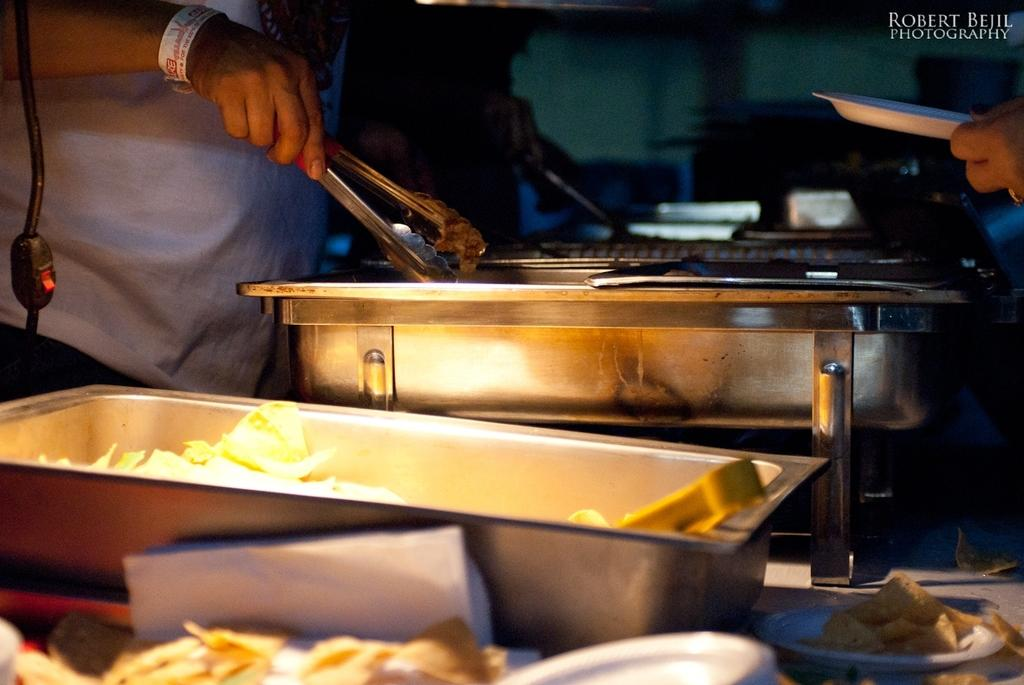What is the person holding in the image? There is a person holding an object in the image. What type of containers can be seen in the image? There are bowls visible in the image. What is the other person holding in the image? There is another person holding a plate in the image. What color is the plate being held by the second person? The plate is white in color. What type of historical punishment is being depicted in the image? There is no historical punishment being depicted in the image; it features two people holding objects and bowls. What type of apparel is the person wearing in the image? The provided facts do not mention any specific apparel worn by the person in the image. 